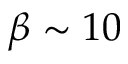<formula> <loc_0><loc_0><loc_500><loc_500>\beta \sim 1 0</formula> 